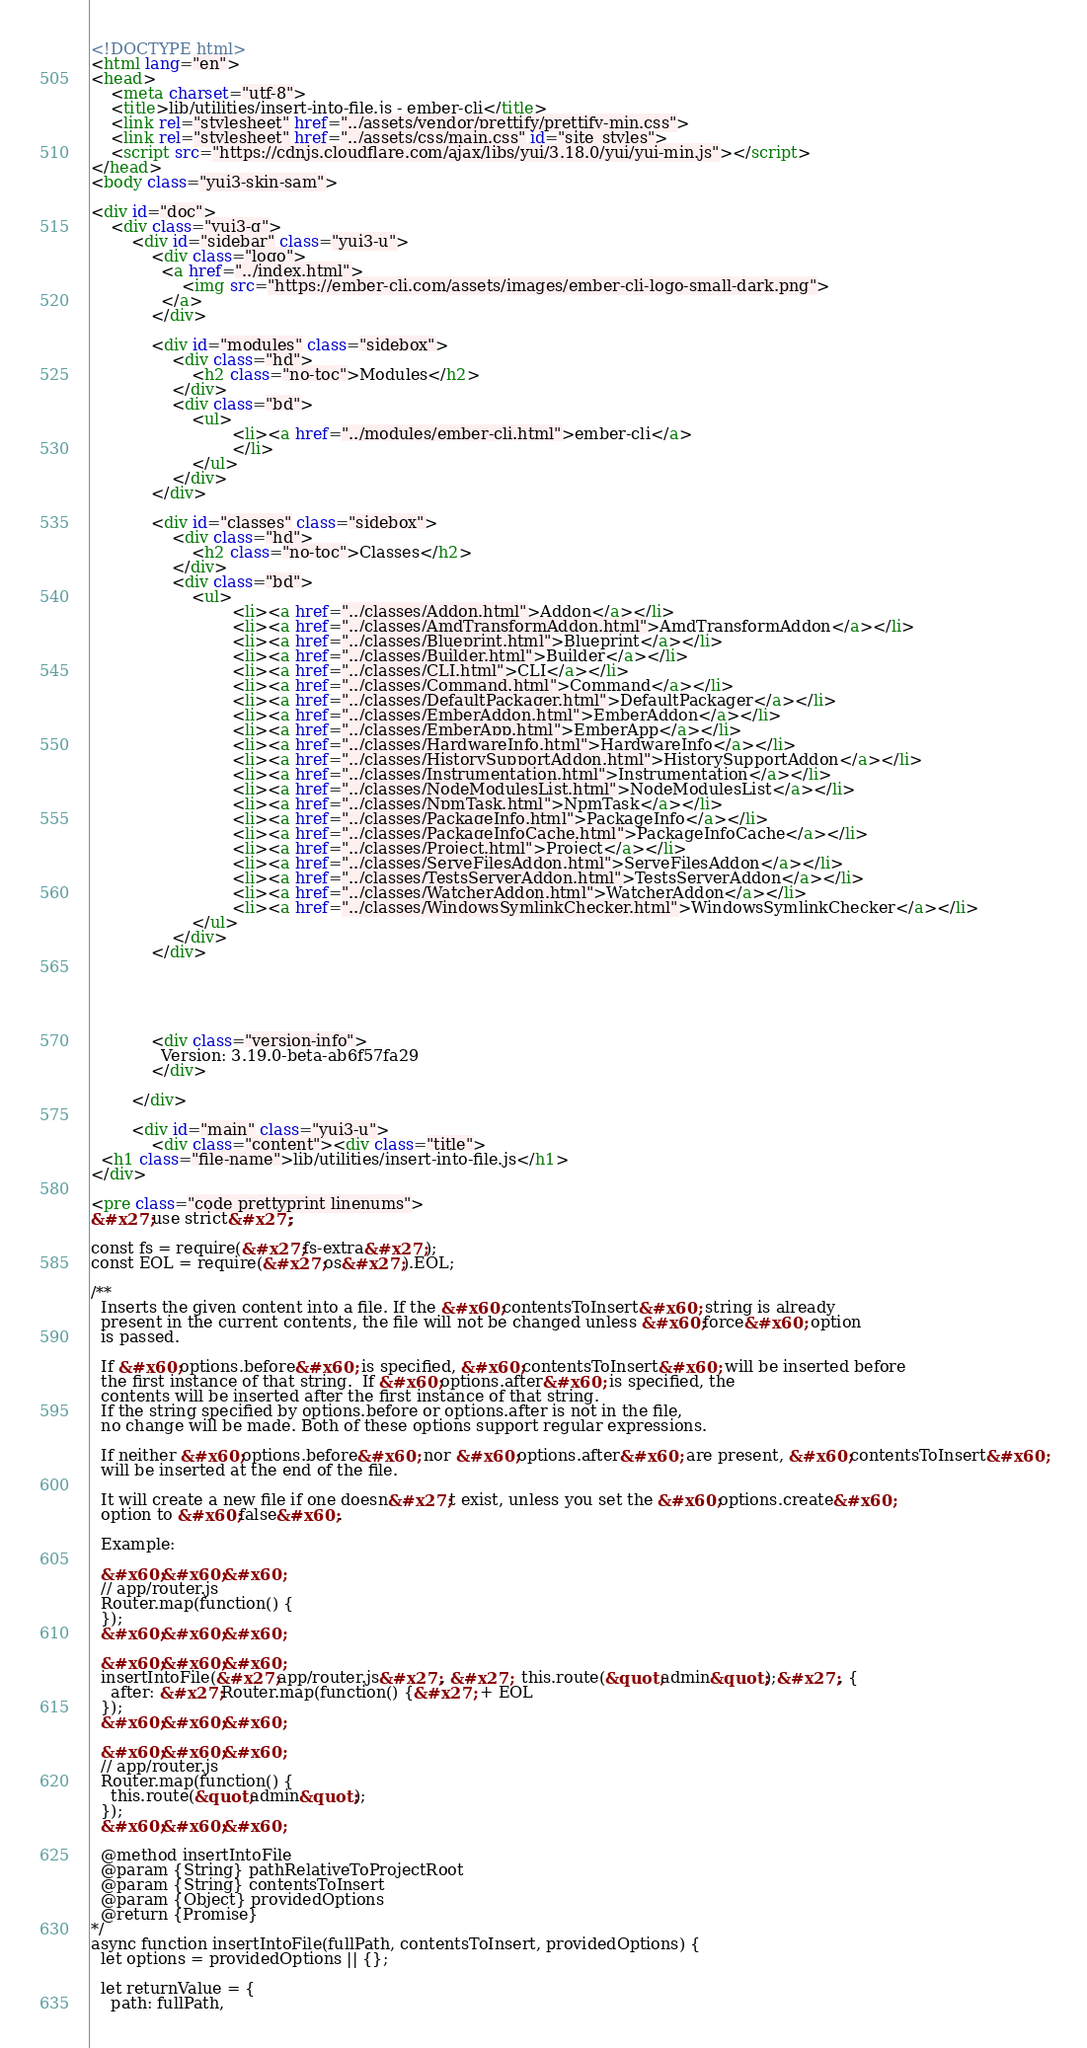Convert code to text. <code><loc_0><loc_0><loc_500><loc_500><_HTML_><!DOCTYPE html>
<html lang="en">
<head>
    <meta charset="utf-8">
    <title>lib/utilities/insert-into-file.js - ember-cli</title>
    <link rel="stylesheet" href="../assets/vendor/prettify/prettify-min.css">
    <link rel="stylesheet" href="../assets/css/main.css" id="site_styles">
    <script src="https://cdnjs.cloudflare.com/ajax/libs/yui/3.18.0/yui/yui-min.js"></script>
</head>
<body class="yui3-skin-sam">

<div id="doc">
    <div class="yui3-g">
        <div id="sidebar" class="yui3-u">
            <div class="logo">
              <a href="../index.html">
                  <img src="https://ember-cli.com/assets/images/ember-cli-logo-small-dark.png">
              </a>
            </div>
            
            <div id="modules" class="sidebox">
                <div class="hd">
                    <h2 class="no-toc">Modules</h2>
                </div>
                <div class="bd">
                    <ul>
                            <li><a href="../modules/ember-cli.html">ember-cli</a>
                            </li>
                    </ul>
                </div>
            </div>
            
            <div id="classes" class="sidebox">
                <div class="hd">
                    <h2 class="no-toc">Classes</h2>
                </div>
                <div class="bd">
                    <ul>
                            <li><a href="../classes/Addon.html">Addon</a></li>
                            <li><a href="../classes/AmdTransformAddon.html">AmdTransformAddon</a></li>
                            <li><a href="../classes/Blueprint.html">Blueprint</a></li>
                            <li><a href="../classes/Builder.html">Builder</a></li>
                            <li><a href="../classes/CLI.html">CLI</a></li>
                            <li><a href="../classes/Command.html">Command</a></li>
                            <li><a href="../classes/DefaultPackager.html">DefaultPackager</a></li>
                            <li><a href="../classes/EmberAddon.html">EmberAddon</a></li>
                            <li><a href="../classes/EmberApp.html">EmberApp</a></li>
                            <li><a href="../classes/HardwareInfo.html">HardwareInfo</a></li>
                            <li><a href="../classes/HistorySupportAddon.html">HistorySupportAddon</a></li>
                            <li><a href="../classes/Instrumentation.html">Instrumentation</a></li>
                            <li><a href="../classes/NodeModulesList.html">NodeModulesList</a></li>
                            <li><a href="../classes/NpmTask.html">NpmTask</a></li>
                            <li><a href="../classes/PackageInfo.html">PackageInfo</a></li>
                            <li><a href="../classes/PackageInfoCache.html">PackageInfoCache</a></li>
                            <li><a href="../classes/Project.html">Project</a></li>
                            <li><a href="../classes/ServeFilesAddon.html">ServeFilesAddon</a></li>
                            <li><a href="../classes/TestsServerAddon.html">TestsServerAddon</a></li>
                            <li><a href="../classes/WatcherAddon.html">WatcherAddon</a></li>
                            <li><a href="../classes/WindowsSymlinkChecker.html">WindowsSymlinkChecker</a></li>
                    </ul>
                </div>
            </div>
            
            
            
            
            
            <div class="version-info">
              Version: 3.19.0-beta-ab6f57fa29
            </div>
            
        </div>

        <div id="main" class="yui3-u">
            <div class="content"><div class="title">
  <h1 class="file-name">lib/utilities/insert-into-file.js</h1>
</div>

<pre class="code prettyprint linenums">
&#x27;use strict&#x27;;

const fs = require(&#x27;fs-extra&#x27;);
const EOL = require(&#x27;os&#x27;).EOL;

/**
  Inserts the given content into a file. If the &#x60;contentsToInsert&#x60; string is already
  present in the current contents, the file will not be changed unless &#x60;force&#x60; option
  is passed.

  If &#x60;options.before&#x60; is specified, &#x60;contentsToInsert&#x60; will be inserted before
  the first instance of that string.  If &#x60;options.after&#x60; is specified, the
  contents will be inserted after the first instance of that string.
  If the string specified by options.before or options.after is not in the file,
  no change will be made. Both of these options support regular expressions.

  If neither &#x60;options.before&#x60; nor &#x60;options.after&#x60; are present, &#x60;contentsToInsert&#x60;
  will be inserted at the end of the file.

  It will create a new file if one doesn&#x27;t exist, unless you set the &#x60;options.create&#x60;
  option to &#x60;false&#x60;.

  Example:

  &#x60;&#x60;&#x60;
  // app/router.js
  Router.map(function() {
  });
  &#x60;&#x60;&#x60;

  &#x60;&#x60;&#x60;
  insertIntoFile(&#x27;app/router.js&#x27;, &#x27;  this.route(&quot;admin&quot;);&#x27;, {
    after: &#x27;Router.map(function() {&#x27; + EOL
  });
  &#x60;&#x60;&#x60;

  &#x60;&#x60;&#x60;
  // app/router.js
  Router.map(function() {
    this.route(&quot;admin&quot;);
  });
  &#x60;&#x60;&#x60;

  @method insertIntoFile
  @param {String} pathRelativeToProjectRoot
  @param {String} contentsToInsert
  @param {Object} providedOptions
  @return {Promise}
*/
async function insertIntoFile(fullPath, contentsToInsert, providedOptions) {
  let options = providedOptions || {};

  let returnValue = {
    path: fullPath,</code> 